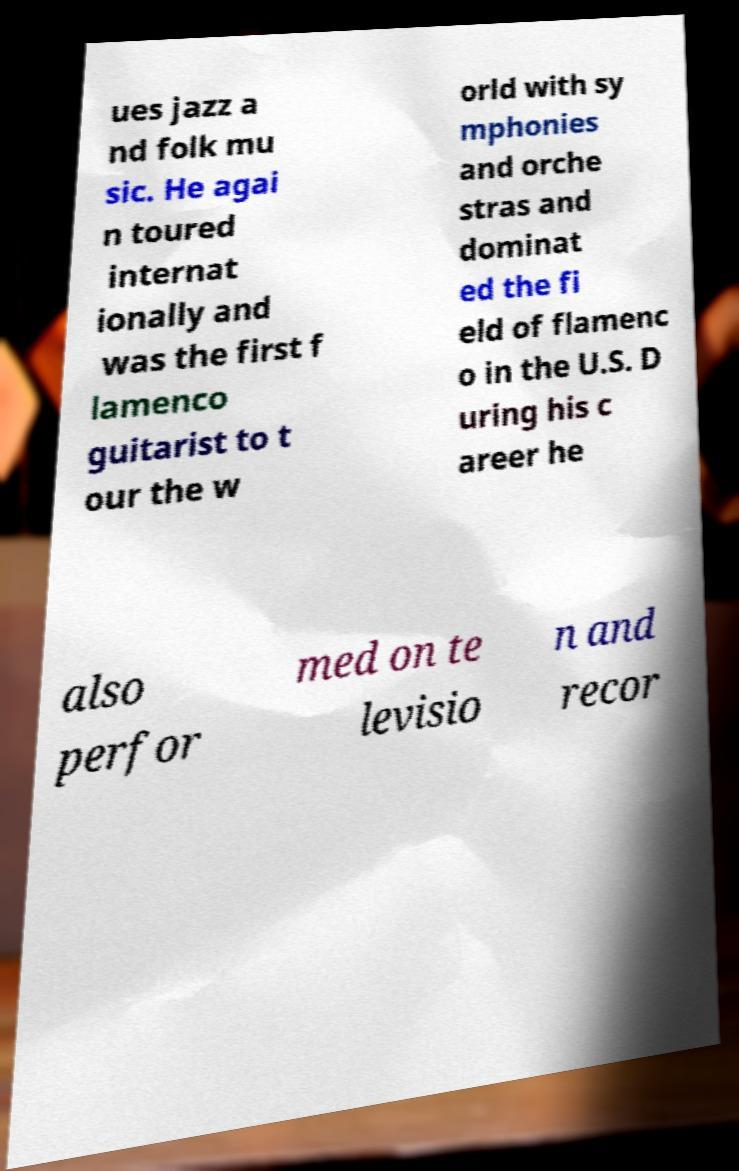Please read and relay the text visible in this image. What does it say? ues jazz a nd folk mu sic. He agai n toured internat ionally and was the first f lamenco guitarist to t our the w orld with sy mphonies and orche stras and dominat ed the fi eld of flamenc o in the U.S. D uring his c areer he also perfor med on te levisio n and recor 